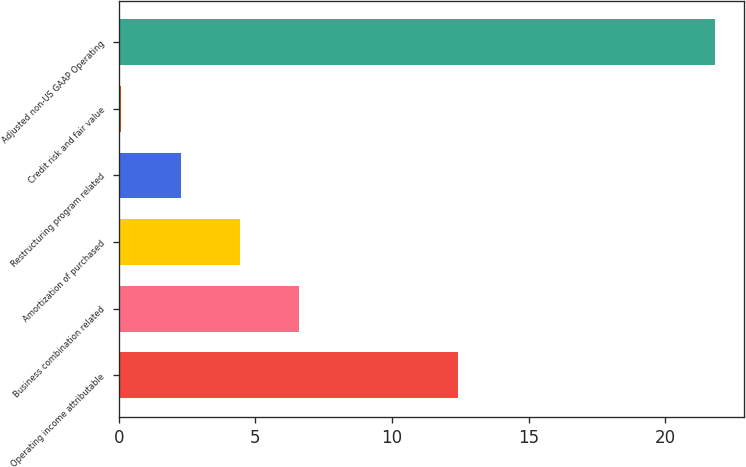Convert chart. <chart><loc_0><loc_0><loc_500><loc_500><bar_chart><fcel>Operating income attributable<fcel>Business combination related<fcel>Amortization of purchased<fcel>Restructuring program related<fcel>Credit risk and fair value<fcel>Adjusted non-US GAAP Operating<nl><fcel>12.4<fcel>6.61<fcel>4.44<fcel>2.27<fcel>0.1<fcel>21.8<nl></chart> 